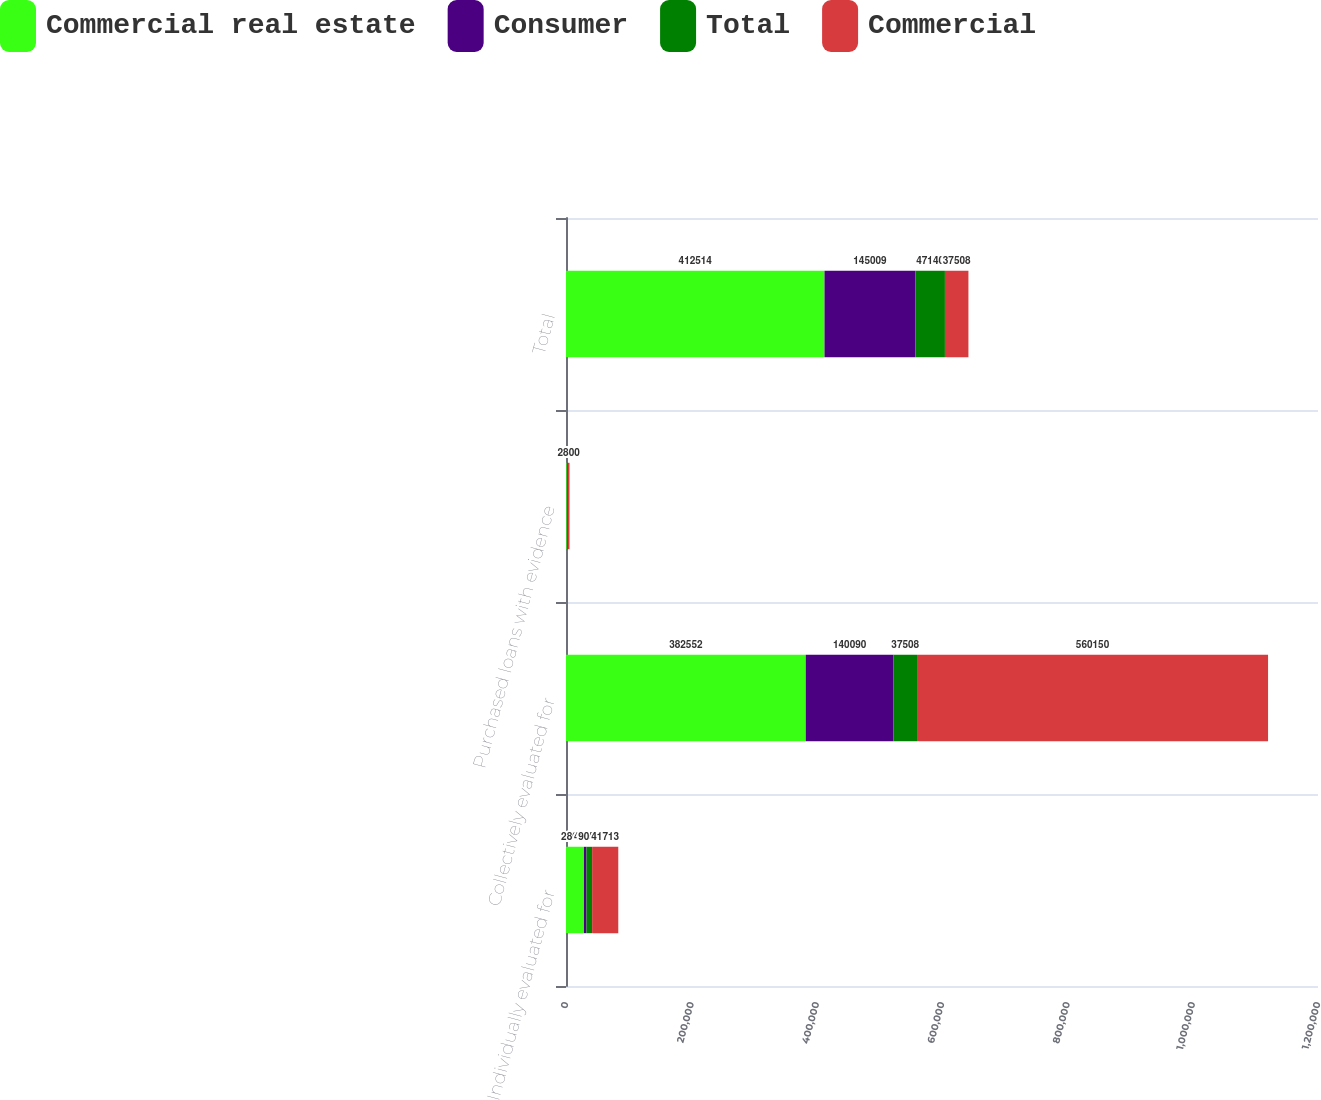<chart> <loc_0><loc_0><loc_500><loc_500><stacked_bar_chart><ecel><fcel>Individually evaluated for<fcel>Collectively evaluated for<fcel>Purchased loans with evidence<fcel>Total<nl><fcel>Commercial real estate<fcel>28627<fcel>382552<fcel>1335<fcel>412514<nl><fcel>Consumer<fcel>4027<fcel>140090<fcel>892<fcel>145009<nl><fcel>Total<fcel>9059<fcel>37508<fcel>573<fcel>47140<nl><fcel>Commercial<fcel>41713<fcel>560150<fcel>2800<fcel>37508<nl></chart> 